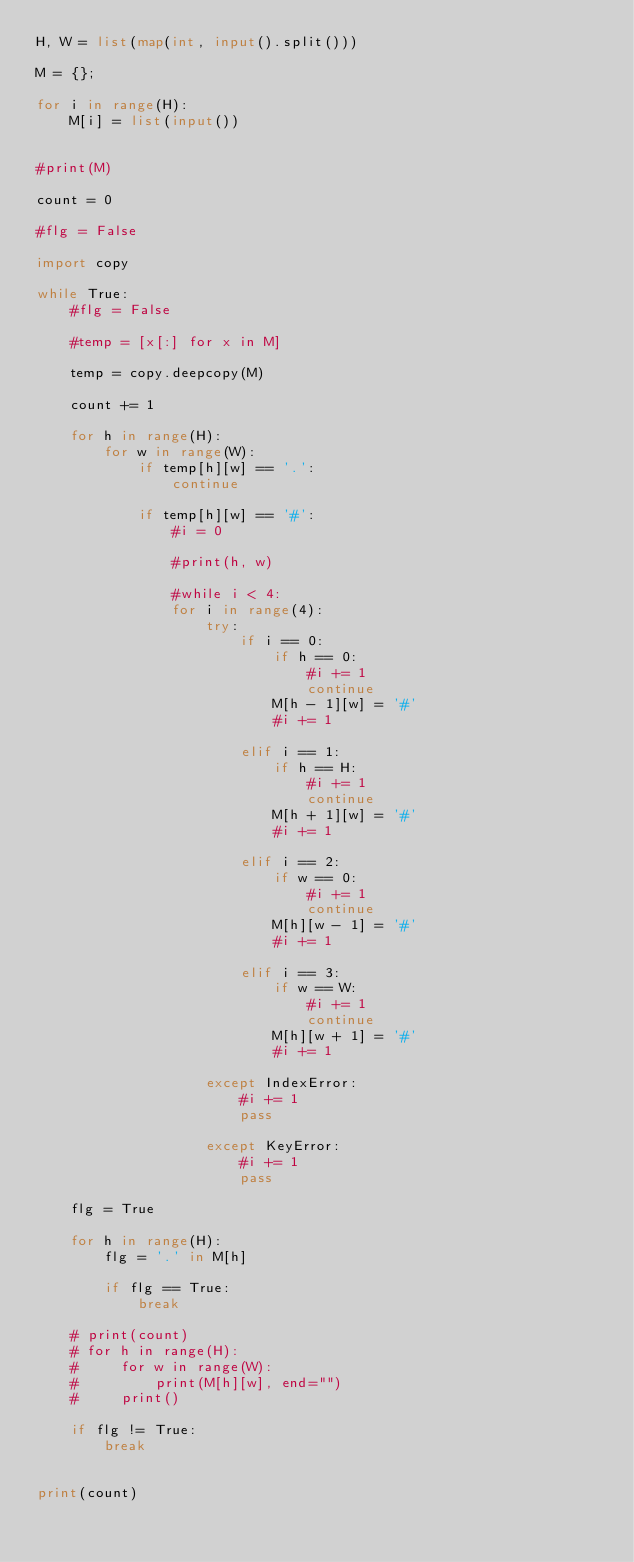<code> <loc_0><loc_0><loc_500><loc_500><_Python_>H, W = list(map(int, input().split()))

M = {};

for i in range(H):
    M[i] = list(input())


#print(M)

count = 0

#flg = False

import copy

while True:
    #flg = False

    #temp = [x[:] for x in M]

    temp = copy.deepcopy(M)

    count += 1

    for h in range(H):
        for w in range(W):
            if temp[h][w] == '.':
                continue

            if temp[h][w] == '#':
                #i = 0

                #print(h, w)

                #while i < 4:
                for i in range(4):
                    try:
                        if i == 0:
                            if h == 0:
                                #i += 1
                                continue
                            M[h - 1][w] = '#'
                            #i += 1

                        elif i == 1:
                            if h == H:
                                #i += 1
                                continue
                            M[h + 1][w] = '#'
                            #i += 1

                        elif i == 2:
                            if w == 0:
                                #i += 1
                                continue
                            M[h][w - 1] = '#'
                            #i += 1

                        elif i == 3:
                            if w == W:
                                #i += 1
                                continue
                            M[h][w + 1] = '#'
                            #i += 1

                    except IndexError:
                        #i += 1
                        pass

                    except KeyError:
                        #i += 1
                        pass

    flg = True

    for h in range(H):
        flg = '.' in M[h]   

        if flg == True:
            break

    # print(count)
    # for h in range(H):
    #     for w in range(W):
    #         print(M[h][w], end="")
    #     print()

    if flg != True:
        break


print(count)</code> 